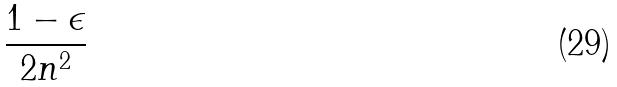<formula> <loc_0><loc_0><loc_500><loc_500>\frac { 1 - \epsilon } { 2 n ^ { 2 } }</formula> 